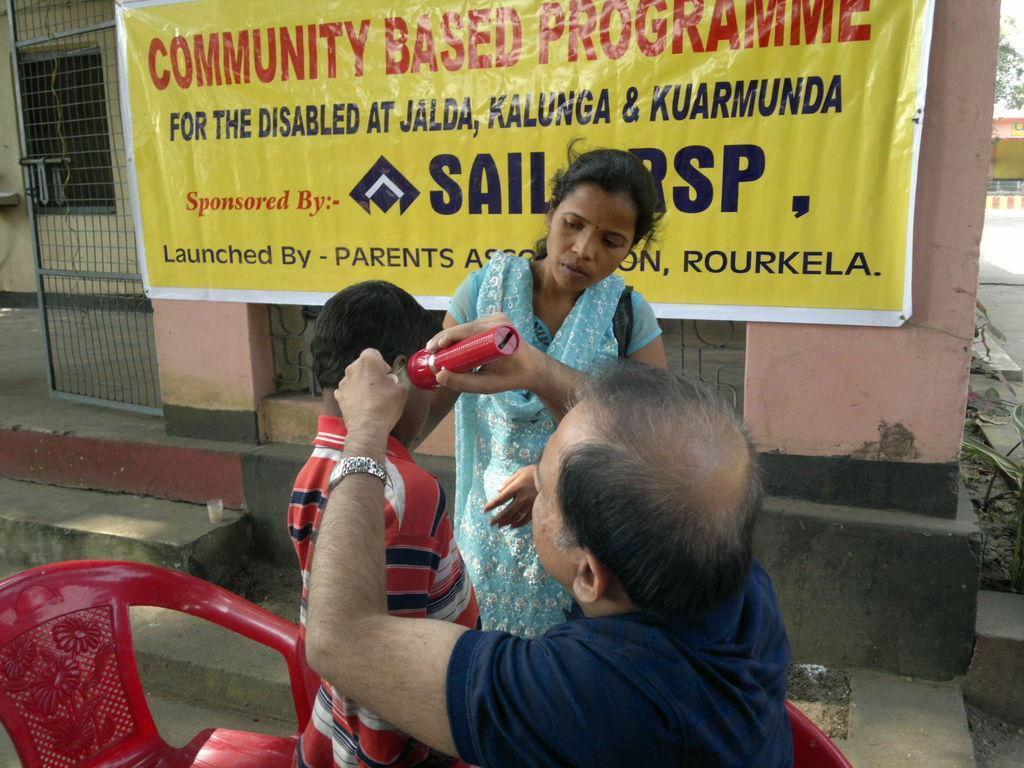Could you give a brief overview of what you see in this image? There is one man holding a torch as we can see at the bottom of this image. There is one woman and a kid standing behind this person. There is a chair in the bottom left corner of this image and there is a building in the background. We can see a banner at the top of this image. 